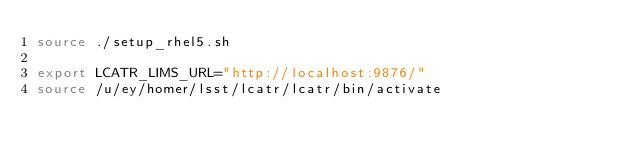<code> <loc_0><loc_0><loc_500><loc_500><_Bash_>source ./setup_rhel5.sh

export LCATR_LIMS_URL="http://localhost:9876/"
source /u/ey/homer/lsst/lcatr/lcatr/bin/activate
</code> 